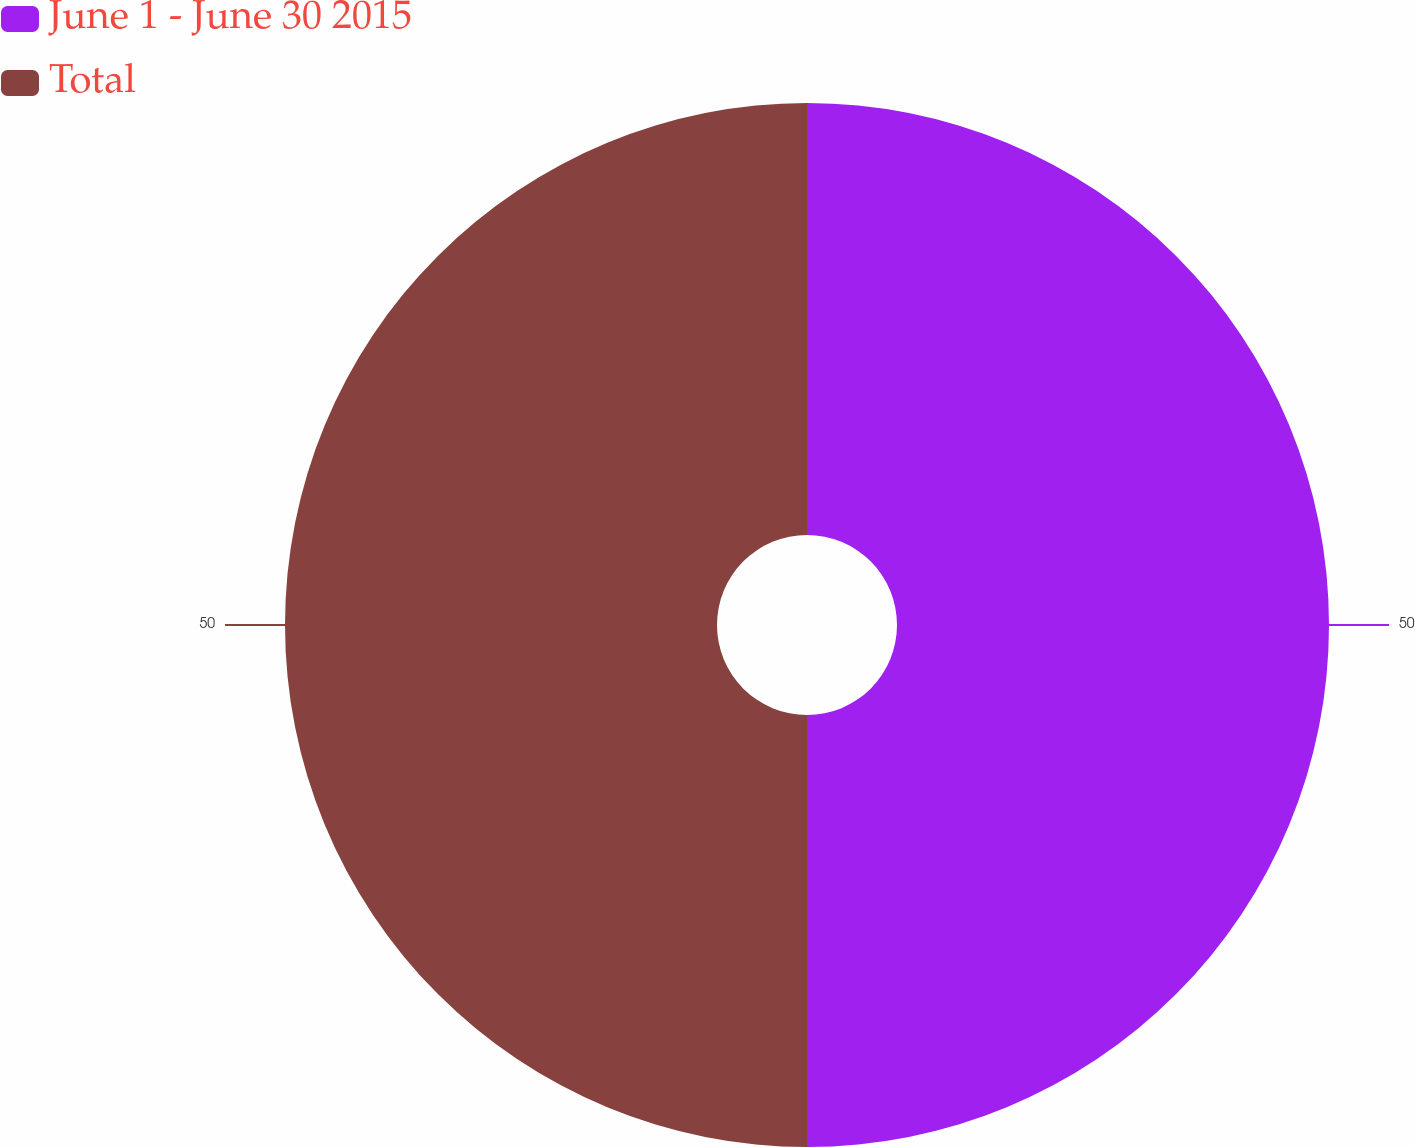Convert chart. <chart><loc_0><loc_0><loc_500><loc_500><pie_chart><fcel>June 1 - June 30 2015<fcel>Total<nl><fcel>50.0%<fcel>50.0%<nl></chart> 